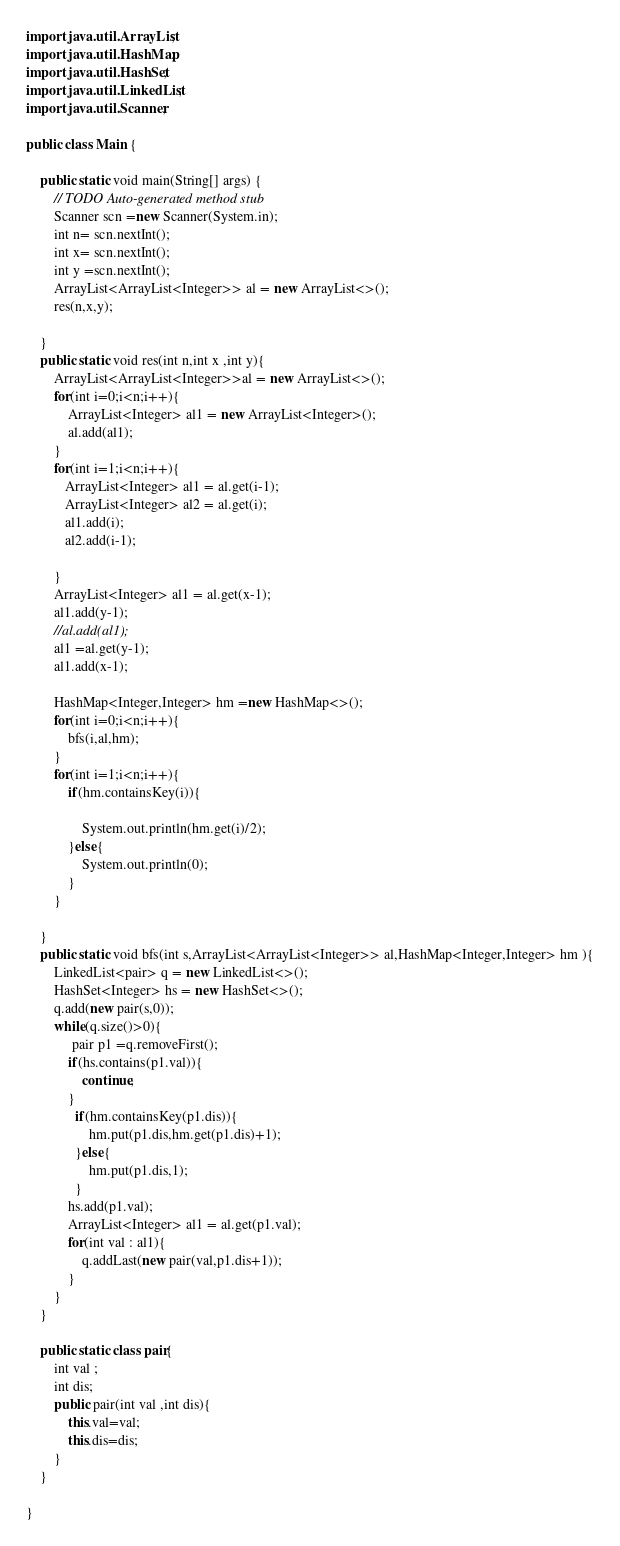<code> <loc_0><loc_0><loc_500><loc_500><_Java_>import java.util.ArrayList;
import java.util.HashMap;
import java.util.HashSet;
import java.util.LinkedList;
import java.util.Scanner;

public class Main {

	public static void main(String[] args) {
		// TODO Auto-generated method stub
		Scanner scn =new Scanner(System.in);
		int n= scn.nextInt();
		int x= scn.nextInt();
		int y =scn.nextInt();
		ArrayList<ArrayList<Integer>> al = new ArrayList<>();
		res(n,x,y);

	}
	public static void res(int n,int x ,int y){
		ArrayList<ArrayList<Integer>>al = new ArrayList<>();
		for(int i=0;i<n;i++){
			ArrayList<Integer> al1 = new ArrayList<Integer>();
			al.add(al1);
		}
		for(int i=1;i<n;i++){
		   ArrayList<Integer> al1 = al.get(i-1);
		   ArrayList<Integer> al2 = al.get(i);
		   al1.add(i);
		   al2.add(i-1);
		   
		}
		ArrayList<Integer> al1 = al.get(x-1);
		al1.add(y-1);
		//al.add(al1);
		al1 =al.get(y-1);
		al1.add(x-1);
		
		HashMap<Integer,Integer> hm =new HashMap<>();
		for(int i=0;i<n;i++){
			bfs(i,al,hm);
		}
		for(int i=1;i<n;i++){
			if(hm.containsKey(i)){
			
				System.out.println(hm.get(i)/2);
			}else{
				System.out.println(0);
			}
		}
	
	}
	public static void bfs(int s,ArrayList<ArrayList<Integer>> al,HashMap<Integer,Integer> hm ){
		LinkedList<pair> q = new LinkedList<>();
		HashSet<Integer> hs = new HashSet<>();
		q.add(new pair(s,0));
		while(q.size()>0){
		     pair p1 =q.removeFirst();
			if(hs.contains(p1.val)){
				continue;
			}
			  if(hm.containsKey(p1.dis)){
				  hm.put(p1.dis,hm.get(p1.dis)+1);
			  }else{
				  hm.put(p1.dis,1);
			  }
			hs.add(p1.val);
			ArrayList<Integer> al1 = al.get(p1.val);
			for(int val : al1){
				q.addLast(new pair(val,p1.dis+1));
			}
		}
	}
	
	public static class pair{
		int val ;
		int dis;
		public pair(int val ,int dis){
			this.val=val;
			this.dis=dis;
		}
	}

}</code> 